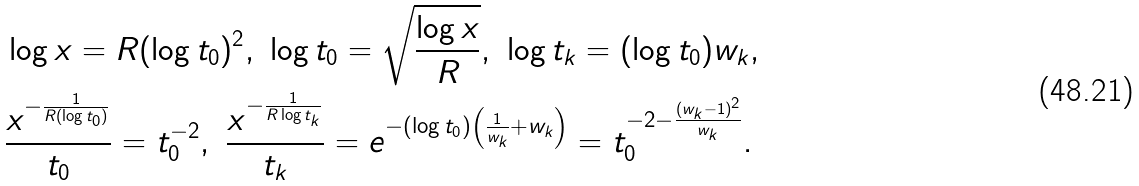Convert formula to latex. <formula><loc_0><loc_0><loc_500><loc_500>& \log x = R ( \log t _ { 0 } ) ^ { 2 } , \ \log t _ { 0 } = \sqrt { \frac { \log x } { R } } , \ \log t _ { k } = ( \log t _ { 0 } ) w _ { k } , \\ \ & \frac { x ^ { - \frac { 1 } { R ( \log t _ { 0 } ) } } } { t _ { 0 } } = t _ { 0 } ^ { - 2 } , \ \frac { x ^ { - \frac { 1 } { R \log t _ { k } } } } { t _ { k } } = e ^ { - ( \log t _ { 0 } ) \left ( \frac { 1 } { w _ { k } } + w _ { k } \right ) } = t _ { 0 } ^ { - 2 - \frac { ( w _ { k } - 1 ) ^ { 2 } } { w _ { k } } } .</formula> 